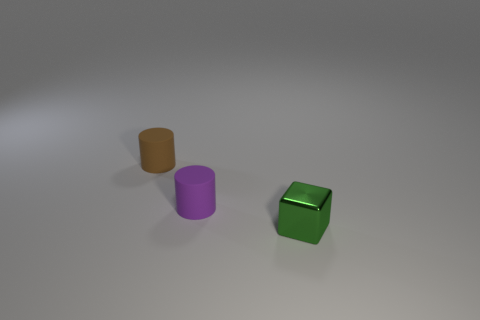Are there any other things that are the same color as the small cube?
Offer a terse response. No. What shape is the matte thing in front of the tiny matte thing left of the matte object on the right side of the tiny brown matte cylinder?
Keep it short and to the point. Cylinder. The other object that is the same shape as the brown rubber thing is what color?
Ensure brevity in your answer.  Purple. The small rubber cylinder in front of the small brown cylinder that is behind the purple matte thing is what color?
Provide a short and direct response. Purple. What size is the other rubber object that is the same shape as the small brown thing?
Offer a terse response. Small. What number of small cylinders are the same material as the green thing?
Provide a succinct answer. 0. There is a tiny object right of the purple object; how many tiny objects are behind it?
Make the answer very short. 2. There is a green shiny object; are there any small brown rubber cylinders in front of it?
Keep it short and to the point. No. There is a small matte thing on the right side of the brown cylinder; does it have the same shape as the tiny green metallic object?
Offer a very short reply. No. What number of tiny rubber cylinders are the same color as the shiny block?
Give a very brief answer. 0. 